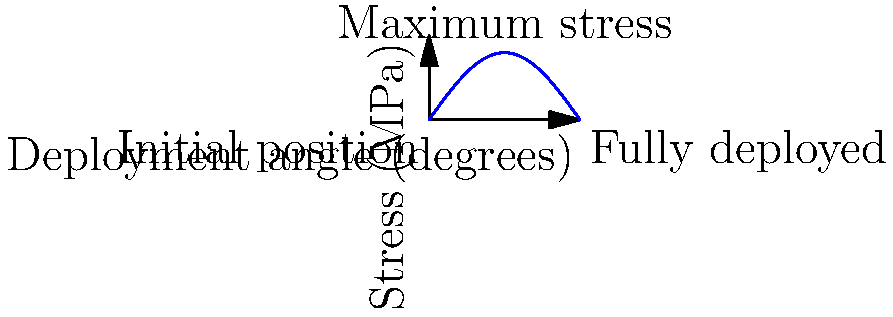Based on the stress distribution curve shown for a satellite's solar panel during deployment, at what deployment angle (in degrees) does the panel experience maximum stress? How does this relate to the panel's position relative to the satellite body? To determine the deployment angle at which the solar panel experiences maximum stress, we need to analyze the given stress distribution curve:

1. The x-axis represents the deployment angle from 0° to 180°.
2. The y-axis represents the stress in MPa from 0 to 100.
3. The curve appears to be sinusoidal, with stress increasing from 0° to a peak and then decreasing to 180°.

To find the maximum stress:

4. Observe that the peak of the curve occurs at 90°.
5. This corresponds to the midpoint of the deployment process.

Relating this to the panel's position:

6. At 0°, the panel is in its initial, folded position against the satellite body (minimum stress).
7. At 90°, the panel is perpendicular to the satellite body (maximum stress).
8. At 180°, the panel is fully deployed (minimum stress again).

The maximum stress occurs at 90° because:

9. This position creates the largest moment arm relative to the hinge.
10. The gravitational and inertial forces acting on the panel create maximum torque at this angle.

Understanding this stress distribution is crucial for designing deployment mechanisms and structural supports that can withstand the peak stresses during the critical phases of deployment.
Answer: 90°; perpendicular to satellite body 